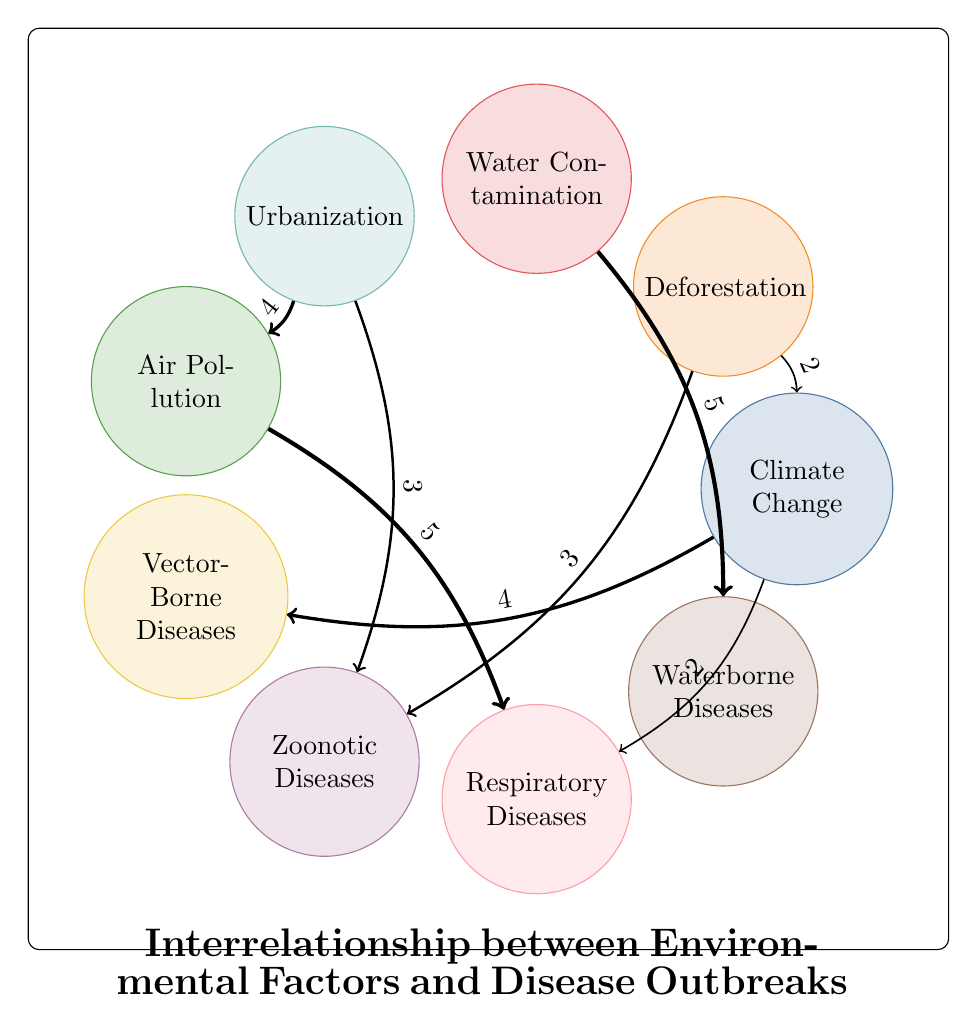What is the total number of nodes in the diagram? The diagram lists individual elements that are interconnected. By counting each unique element, we find that there are 9 nodes represented.
Answer: 9 Which disease is most associated with water contamination? The diagram indicates a direct link from "Water Contamination" to "Waterborne Diseases" with the highest value of 5. This means "Waterborne Diseases" is strongly associated with water contamination.
Answer: Waterborne Diseases How many connections does urbanization have? By inspecting the diagram, we can see that "Urbanization" connects to "Zoonotic Diseases" (3) and "Air Pollution" (4), making a total of 2 connections.
Answer: 2 What environmental factor has the strongest relationship with respiratory diseases? Looking at the links directed towards "Respiratory Diseases," we see that "Air Pollution" has the highest value of 5, indicating it has the strongest relationship.
Answer: Air Pollution What is the value of the connection from deforestation to zoonotic diseases? The diagram shows a link from "Deforestation" to "Zoonotic Diseases" with a value of 3, representing the strength of their connection.
Answer: 3 Which disease is linked to climate change with the least value? While "Climate Change" connects to both "Vector-Borne Diseases" (4) and "Respiratory Diseases" (2), the link to "Respiratory Diseases" holds the lowest value of 2.
Answer: Respiratory Diseases Is there a connection from deforestation back to climate change? Yes, the diagram indicates a link from "Deforestation" to "Climate Change" with a value of 2, showing a cyclical relationship.
Answer: Yes Which disease has connections to two different environmental factors? The only disease linked to multiple environmental factors is "Zoonotic Diseases," with connections to "Deforestation" (3) and "Urbanization" (3).
Answer: Zoonotic Diseases What fraction of the total edges involves air pollution? There are a total of 7 edges in the diagram, and "Air Pollution" is connected to "Urbanization" and "Respiratory Diseases," leading to 2 edges associated with it. Therefore, the fraction is 2 out of 7.
Answer: 2/7 